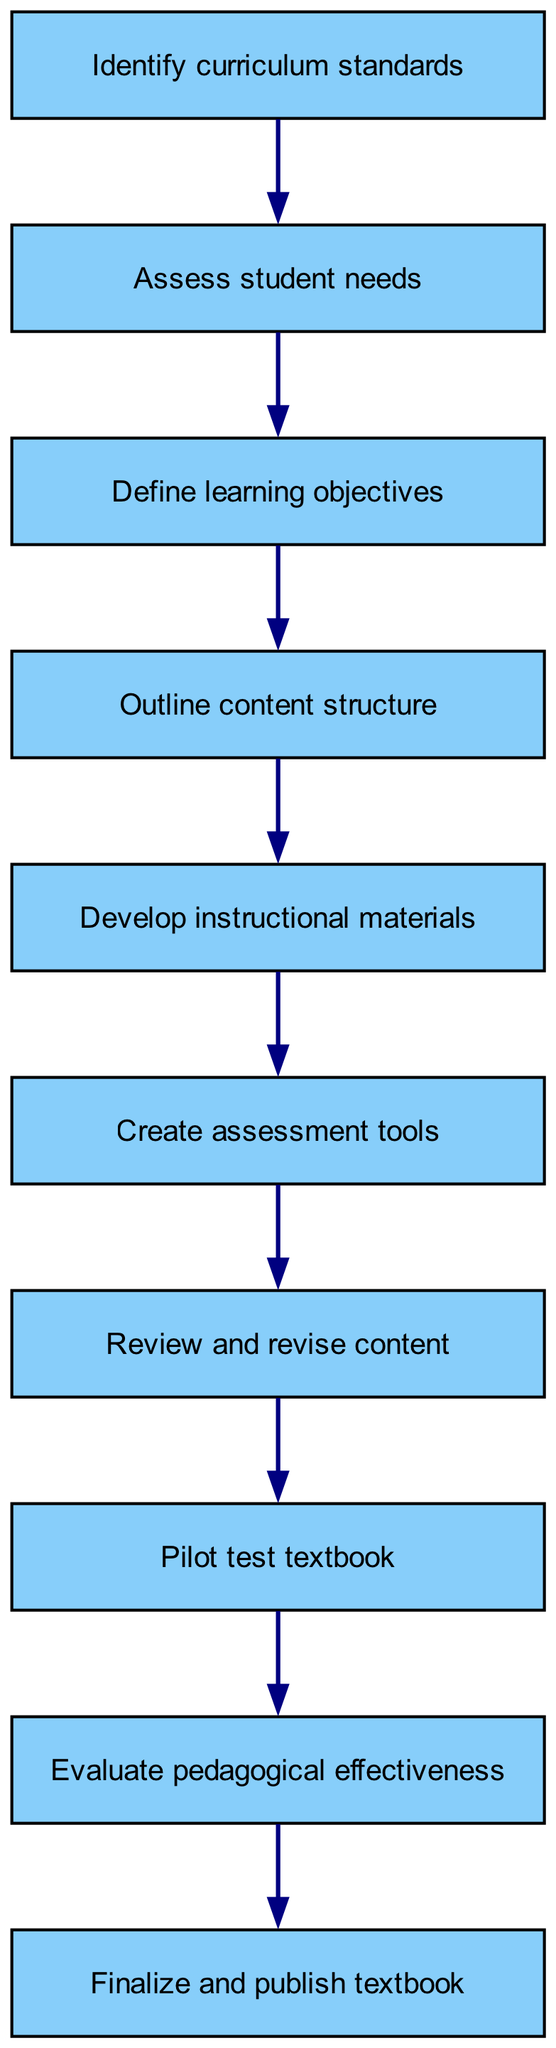What is the first step in the curriculum development process? The first step is represented by the first node in the diagram, which is "Identify curriculum standards."
Answer: Identify curriculum standards How many total steps are there in the process? By counting the nodes in the diagram, there are a total of ten steps from start to finish.
Answer: Ten What step comes after defining learning objectives? In the diagram, the step following "Define learning objectives" is "Outline content structure," as indicated by the arrow connecting the two.
Answer: Outline content structure What step involves creating tools to assess student learning? The node labeled "Create assessment tools" indicates the stage where tools for evaluating student learning are developed.
Answer: Create assessment tools Which step is focused on reviewing and improving the content? The step labeled "Review and revise content" specifies the focus on improving the materials created in earlier steps.
Answer: Review and revise content What is the purpose of the step immediately before finalizing and publishing the textbook? This step, "Evaluate pedagogical effectiveness," is critical for determining the quality and educational impact of the textbook prior to publication.
Answer: Evaluate pedagogical effectiveness Which steps are directly connected to the development of instructional materials? The steps "Outline content structure" and "Create assessment tools" are both directly connected to "Develop instructional materials" by the arrows showing the flow of the process.
Answer: Outline content structure, Create assessment tools How does pilot testing fit into the overall curriculum development process? Pilot testing is a crucial step that occurs after reviewing and revising the content, ensuring the practicality of the textbook in real classroom settings.
Answer: After reviewing and revising content What is the last node in the flow chart? The last node in the diagram is "Finalize and publish textbook," indicating the conclusion of the development process.
Answer: Finalize and publish textbook 